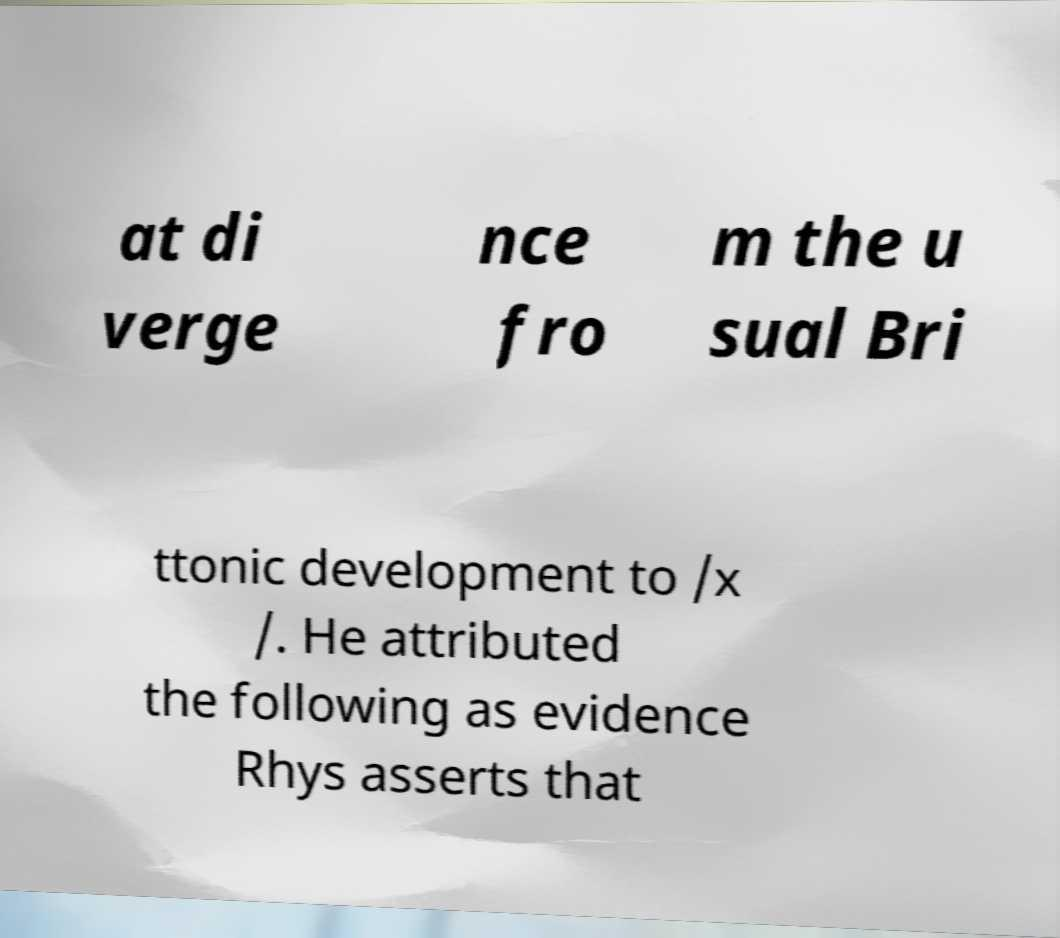Could you extract and type out the text from this image? at di verge nce fro m the u sual Bri ttonic development to /x /. He attributed the following as evidence Rhys asserts that 